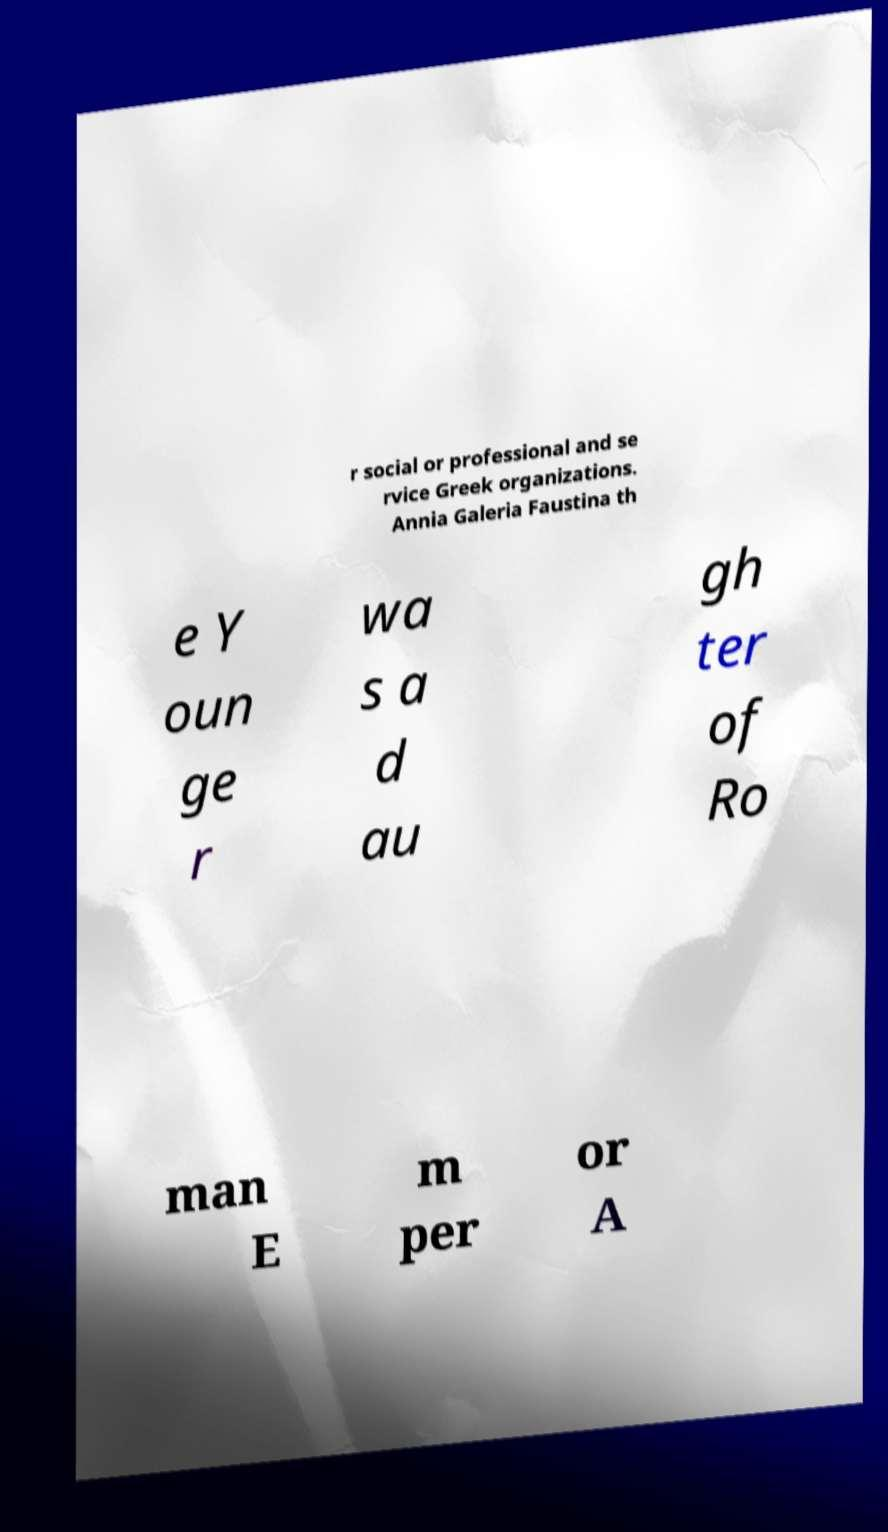Could you extract and type out the text from this image? r social or professional and se rvice Greek organizations. Annia Galeria Faustina th e Y oun ge r wa s a d au gh ter of Ro man E m per or A 